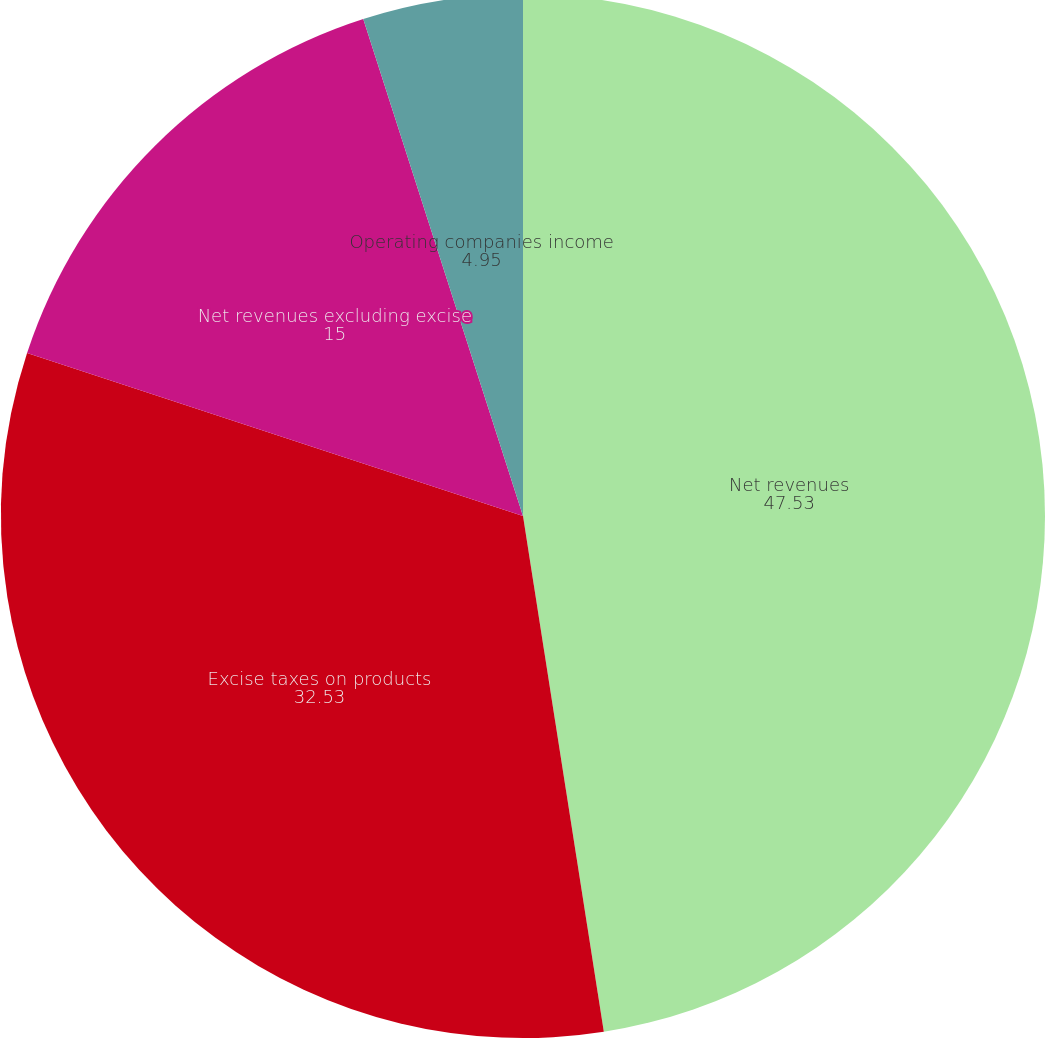<chart> <loc_0><loc_0><loc_500><loc_500><pie_chart><fcel>Net revenues<fcel>Excise taxes on products<fcel>Net revenues excluding excise<fcel>Operating companies income<nl><fcel>47.53%<fcel>32.53%<fcel>15.0%<fcel>4.95%<nl></chart> 